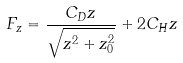<formula> <loc_0><loc_0><loc_500><loc_500>F _ { z } = \frac { C _ { D } z } { \sqrt { z ^ { 2 } + z _ { 0 } ^ { 2 } } } + 2 C _ { H } z</formula> 